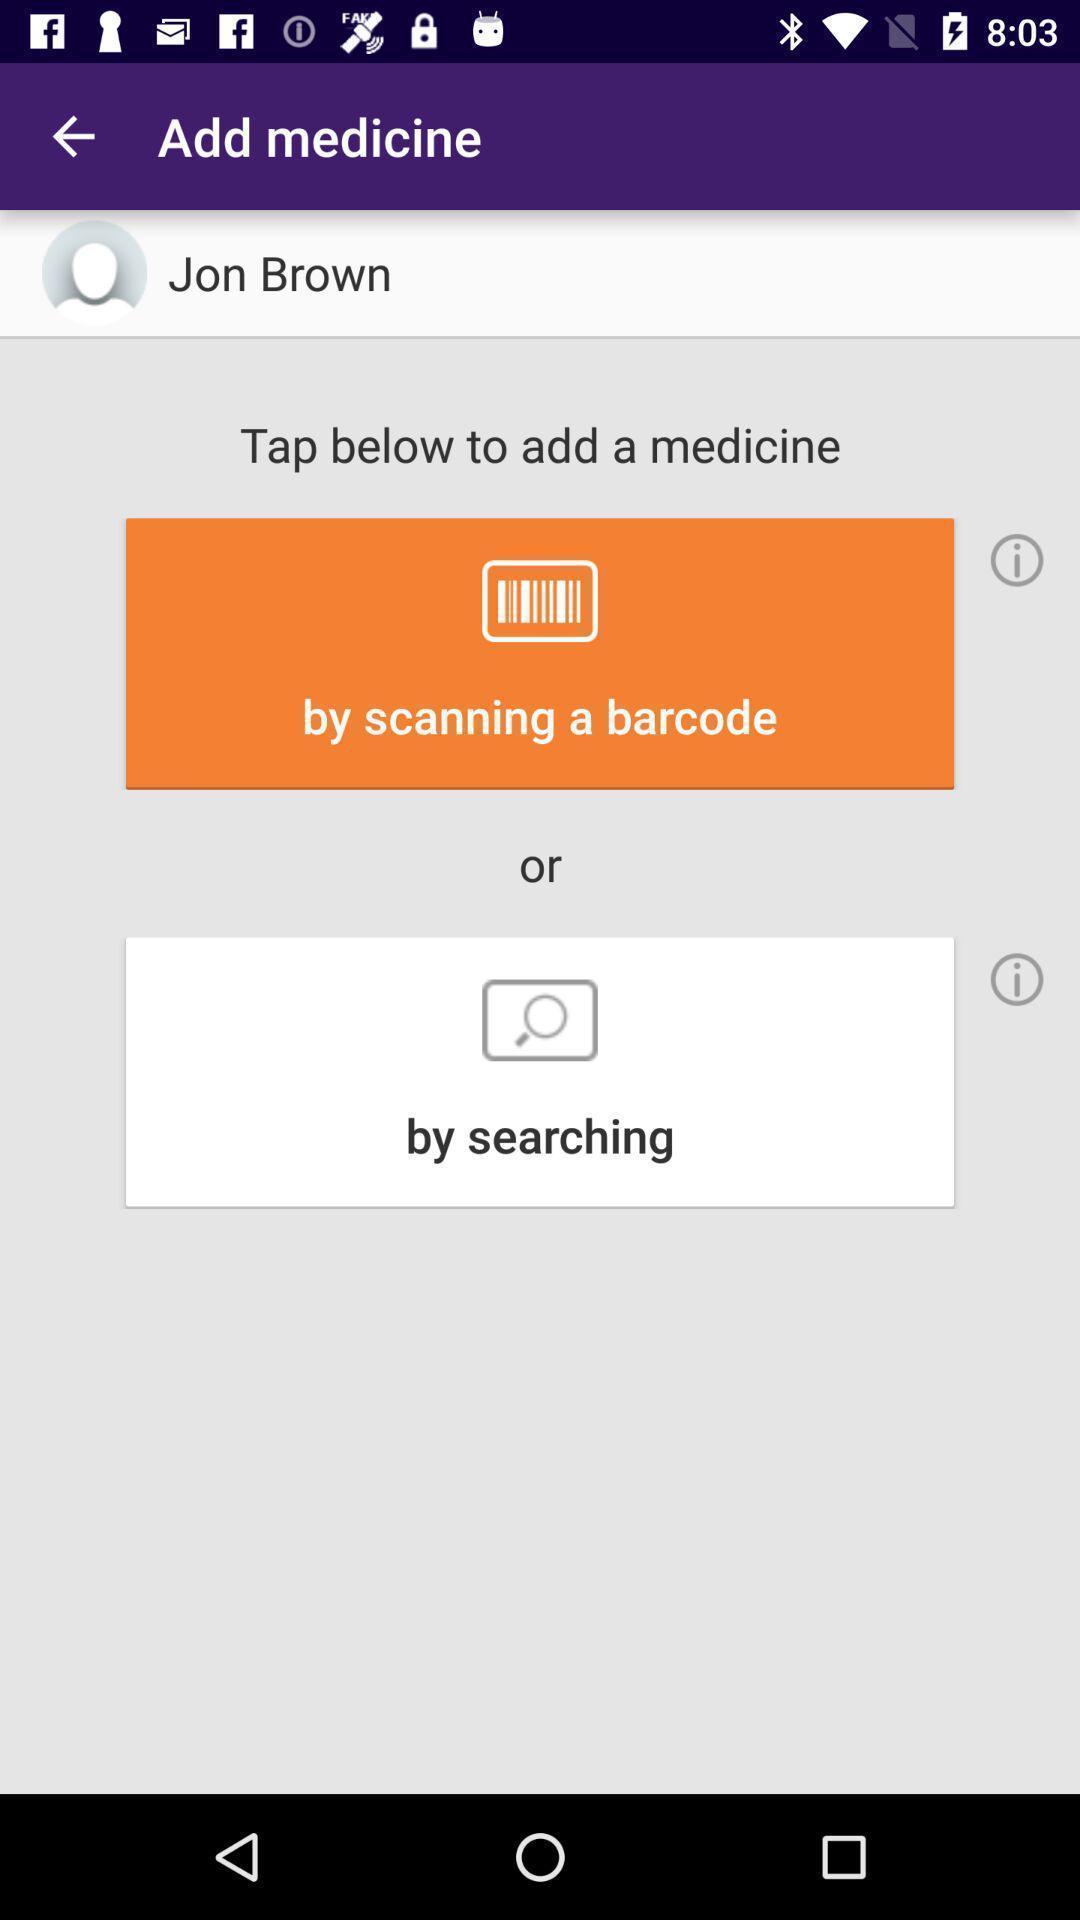Describe the visual elements of this screenshot. Page for adding a medicine in health app. 